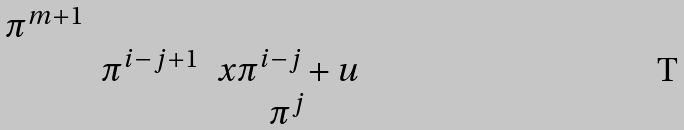<formula> <loc_0><loc_0><loc_500><loc_500>\begin{matrix} \pi ^ { m + 1 } & & \\ & \pi ^ { i - j + 1 } & x \pi ^ { i - j } + u \\ & & \pi ^ { j } \end{matrix}</formula> 